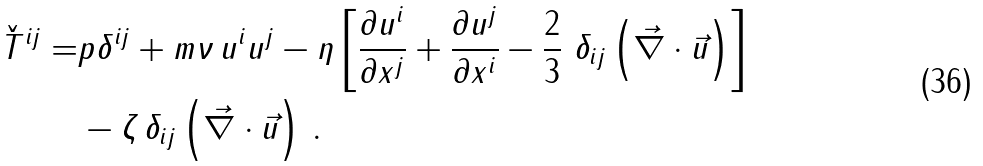Convert formula to latex. <formula><loc_0><loc_0><loc_500><loc_500>\check { T } ^ { i j } = & p \delta ^ { i j } + m \nu \, u ^ { i } u ^ { j } - \eta \left [ \frac { \partial u ^ { i } } { \partial x ^ { j } } + \frac { \partial u ^ { j } } { \partial x ^ { i } } - \frac { 2 } { 3 } \ \delta _ { i j } \left ( \vec { \nabla } \cdot \vec { u } \right ) \right ] \\ & - \zeta \, \delta _ { i j } \left ( \vec { \nabla } \cdot \vec { u } \right ) \, .</formula> 